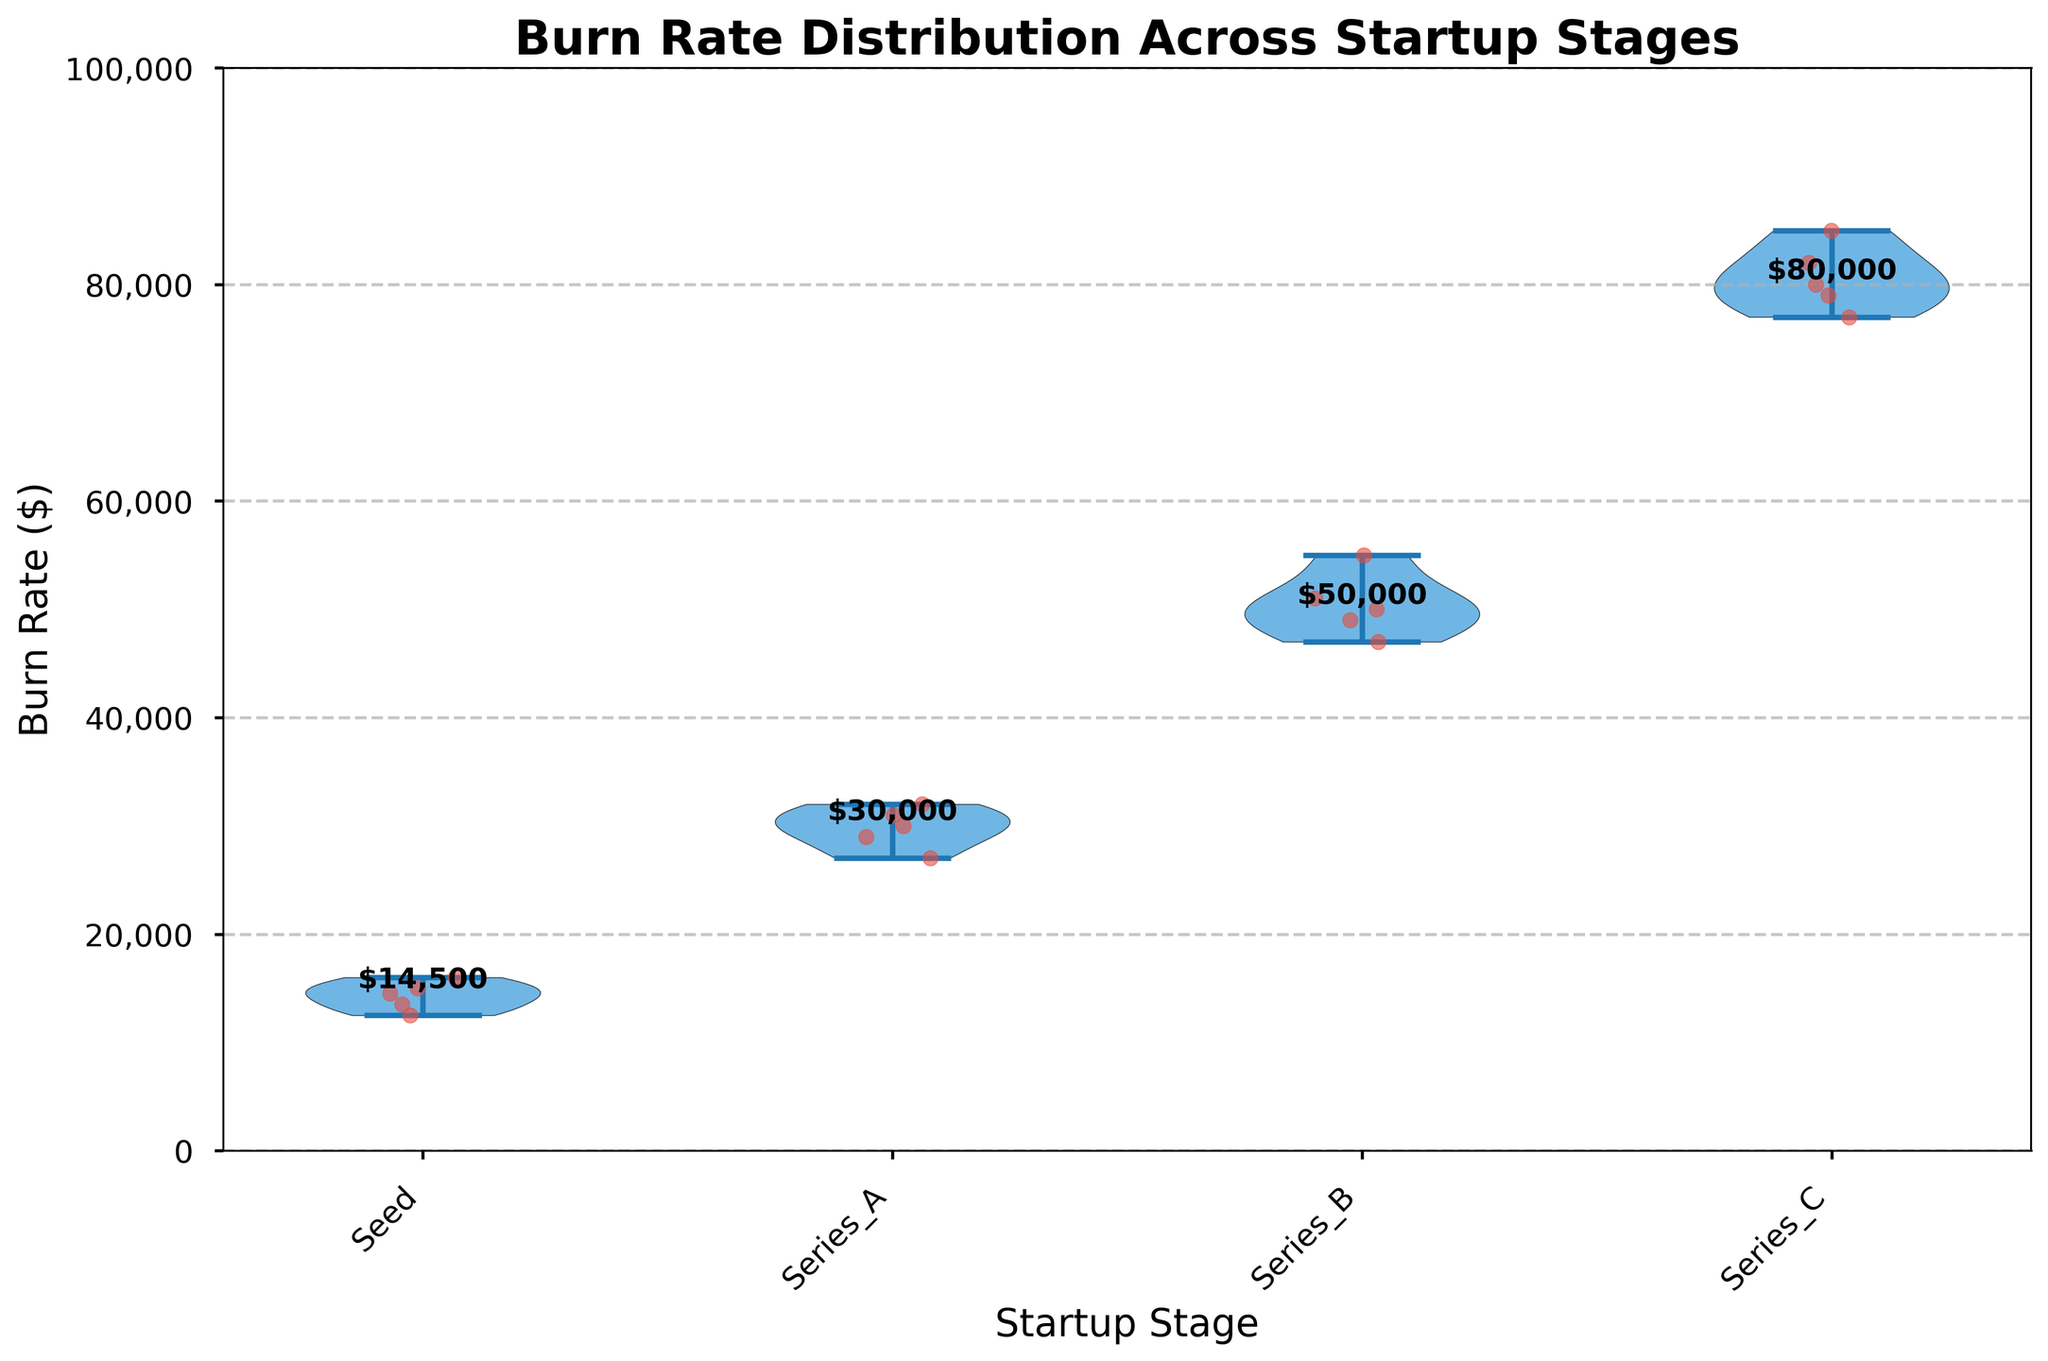What is the title of the plot? The title of the plot is usually found at the top of the figure in a larger or bold font. This plot's title should be read directly from it.
Answer: Burn Rate Distribution Across Startup Stages How are the burn rates distributed for Series C startups? Violin plots show the distribution of data. In Series C, the violin plot will show a wider middle section, indicating the interquartile range, and jittered points represent individual data values. The overlaying points and the shape of the violin plot suggest the data spread.
Answer: Median around $80,000, ranges approximately $77,000 to $85,000 Which startup stage has the highest median burn rate? Violin plots can display the median values which are sometimes annotated. In this plot, the median value appears as annotated text above the violin for each startup stage.
Answer: Series C How does the burn rate of Seed stage startups compare to Series A startups? By examining the violin shapes and median annotations for both stages, we note that Series A has higher burn rates on average compared to Seed stage startups; the median burn rate of Series A is higher than that of the Seed stage.
Answer: Series A has higher burn rates than Seed What's the median burn rate for Series B startups? Identify the annotated median value for Series B startup stage in the violin plot. It should be annotated near the center of the Series B violin plot.
Answer: $50,000 Is there any overlap in burn rates between Series B and Series C startups? Overlap is observed if the violin plots for Series B and Series C have a range of values that coexist. Examine the shape and spread of the violins for both Series B and Series C to check for any overlapping regions.
Answer: Yes, there is overlap Which stage shows the most variability in burn rates? Look at the width and spread of the violin plots; the wider and more spread out the "violin", the greater the variability. Series C has the broadest range of burn rates, implying higher variability.
Answer: Series C How many startups are in each stage? Count the individual jittered points overlaid on the violin plots for each stage. Each point represents one startup. For example, if there are 5 points for Seed, it indicates 5 startups in Seed stage.
Answer: Equal for all stages (5 each) What are the minimum and maximum burn rates observed in Series A? Minimum and maximum values are at the edges of the violins for Series A. Points furthest to the top or bottom of the violin shapes of Series A indicate the min and max burn rates.
Answer: Min: $27,000, Max: $32,000 